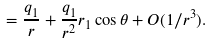<formula> <loc_0><loc_0><loc_500><loc_500>= \frac { q _ { 1 } } r + \frac { q _ { 1 } } { r ^ { 2 } } r _ { 1 } \cos \theta + O ( 1 / r ^ { 3 } ) .</formula> 